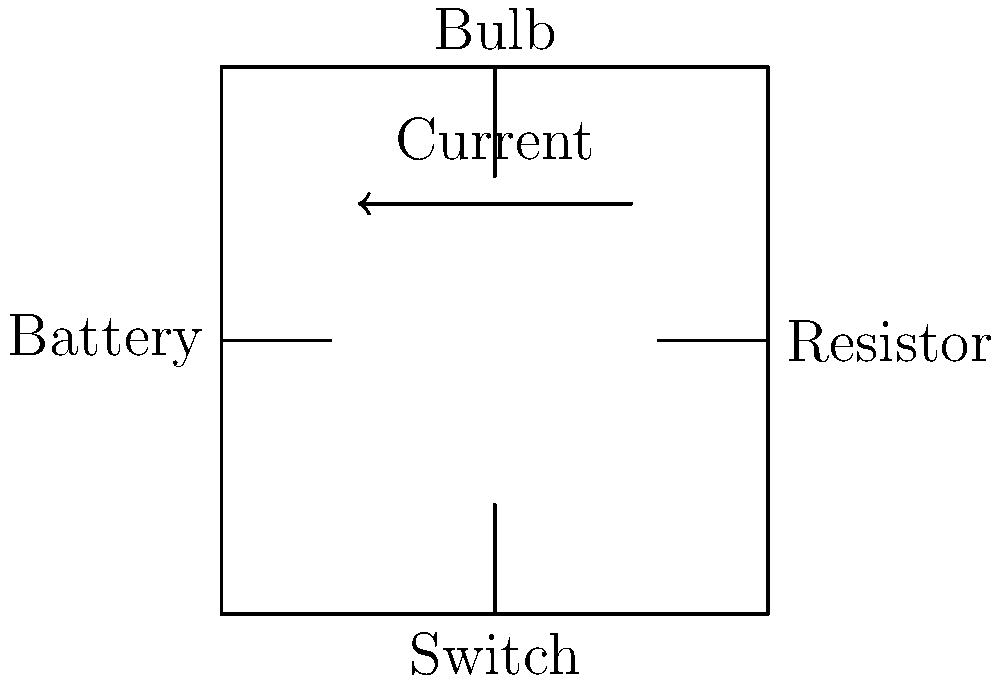As a business owner overseeing a project involving electrical work, you need to understand the basics of electrical circuits. Looking at the diagram provided by your project manager, identify the essential components of this simple electrical circuit and explain how the current flows through it. Let's break down the components and current flow in this simple electrical circuit:

1. Components:
   a) Battery: This is the power source, providing the electrical energy for the circuit.
   b) Resistor: This component controls the flow of current in the circuit.
   c) Switch: This allows you to open or close the circuit, controlling whether current can flow.
   d) Bulb: This is the load in the circuit, which uses the electrical energy to produce light.

2. Current flow:
   a) The battery creates an electrical potential difference (voltage) between its positive and negative terminals.
   b) When the switch is closed, it completes the circuit, allowing current to flow.
   c) Current flows from the positive terminal of the battery through the circuit components.
   d) The current passes through the resistor, which limits the amount of current flowing.
   e) The current then flows through the bulb, causing it to light up.
   f) Finally, the current returns to the negative terminal of the battery.

3. Important points:
   a) Current flows in a complete loop (closed circuit).
   b) The direction of current flow is from the positive to the negative terminal of the battery.
   c) All components in the circuit affect the flow of current.

Understanding these basics helps you grasp the fundamental principles of electrical circuits in your project.
Answer: Battery provides power; current flows from positive to negative through resistor, switch, and bulb in a closed loop. 